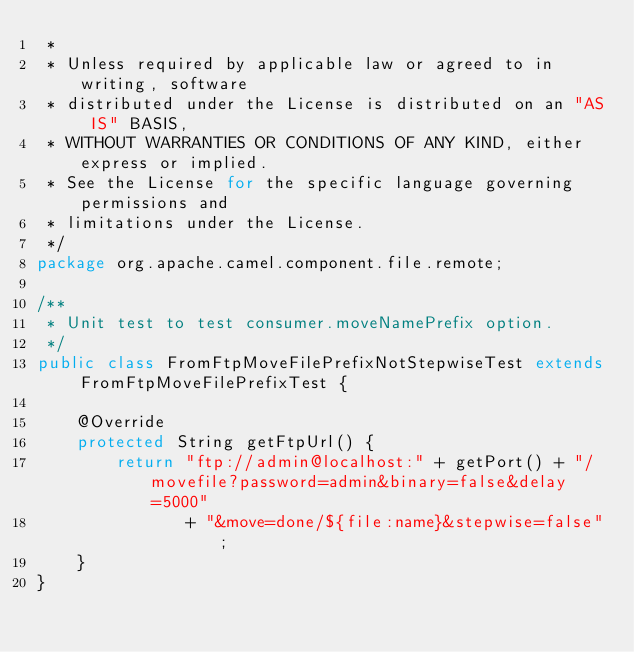Convert code to text. <code><loc_0><loc_0><loc_500><loc_500><_Java_> *
 * Unless required by applicable law or agreed to in writing, software
 * distributed under the License is distributed on an "AS IS" BASIS,
 * WITHOUT WARRANTIES OR CONDITIONS OF ANY KIND, either express or implied.
 * See the License for the specific language governing permissions and
 * limitations under the License.
 */
package org.apache.camel.component.file.remote;

/**
 * Unit test to test consumer.moveNamePrefix option.
 */
public class FromFtpMoveFilePrefixNotStepwiseTest extends FromFtpMoveFilePrefixTest {

    @Override
    protected String getFtpUrl() {
        return "ftp://admin@localhost:" + getPort() + "/movefile?password=admin&binary=false&delay=5000"
               + "&move=done/${file:name}&stepwise=false";
    }
}
</code> 